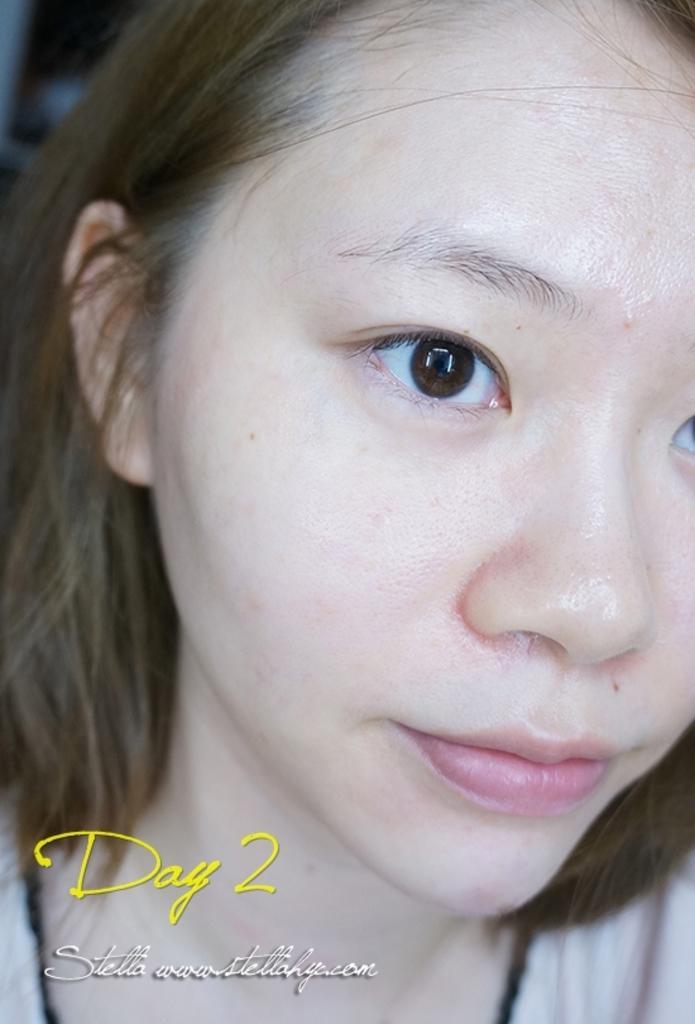In one or two sentences, can you explain what this image depicts? In this image we can see a lady. At the bottom there is text. 